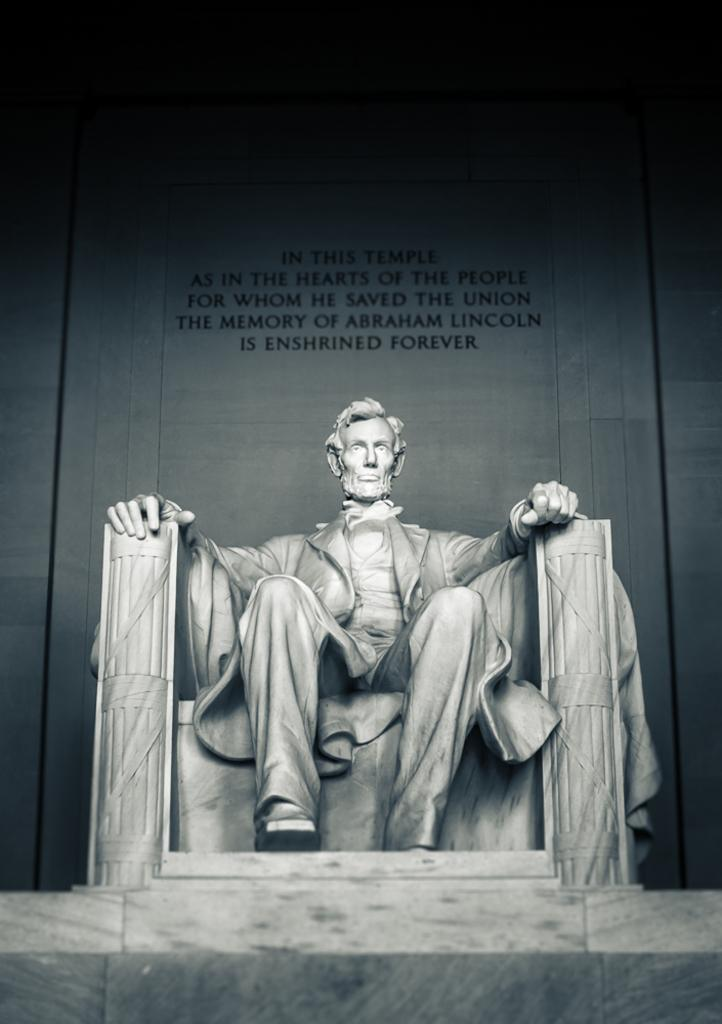What is the main subject of the image? There is a sculpture of a man in the image. What is the man in the sculpture doing? The man is sitting in a chair. What is behind the man in the image? There is a wall behind the man. What can be seen on the wall? The wall has some text on it. What type of pot is being used to weigh the man in the image? There is no pot or weighing activity present in the image. What is the selection of items available for the man to choose from in the image? There is no selection of items or any indication of a choice-making process in the image. 